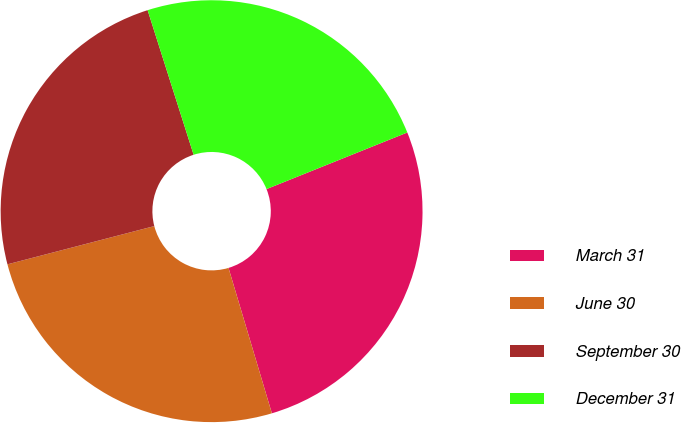Convert chart. <chart><loc_0><loc_0><loc_500><loc_500><pie_chart><fcel>March 31<fcel>June 30<fcel>September 30<fcel>December 31<nl><fcel>26.47%<fcel>25.56%<fcel>24.15%<fcel>23.82%<nl></chart> 